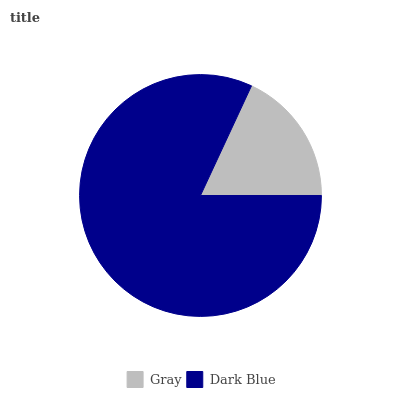Is Gray the minimum?
Answer yes or no. Yes. Is Dark Blue the maximum?
Answer yes or no. Yes. Is Dark Blue the minimum?
Answer yes or no. No. Is Dark Blue greater than Gray?
Answer yes or no. Yes. Is Gray less than Dark Blue?
Answer yes or no. Yes. Is Gray greater than Dark Blue?
Answer yes or no. No. Is Dark Blue less than Gray?
Answer yes or no. No. Is Dark Blue the high median?
Answer yes or no. Yes. Is Gray the low median?
Answer yes or no. Yes. Is Gray the high median?
Answer yes or no. No. Is Dark Blue the low median?
Answer yes or no. No. 